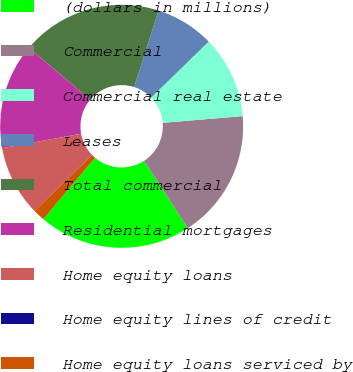<chart> <loc_0><loc_0><loc_500><loc_500><pie_chart><fcel>(dollars in millions)<fcel>Commercial<fcel>Commercial real estate<fcel>Leases<fcel>Total commercial<fcel>Residential mortgages<fcel>Home equity loans<fcel>Home equity lines of credit<fcel>Home equity loans serviced by<nl><fcel>20.31%<fcel>17.18%<fcel>10.94%<fcel>7.81%<fcel>18.74%<fcel>14.06%<fcel>9.38%<fcel>0.01%<fcel>1.57%<nl></chart> 